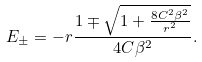Convert formula to latex. <formula><loc_0><loc_0><loc_500><loc_500>E _ { \pm } = - r \frac { 1 \mp \sqrt { 1 + \frac { 8 C ^ { 2 } \beta ^ { 2 } } { r ^ { 2 } } } } { 4 C \beta ^ { 2 } } .</formula> 